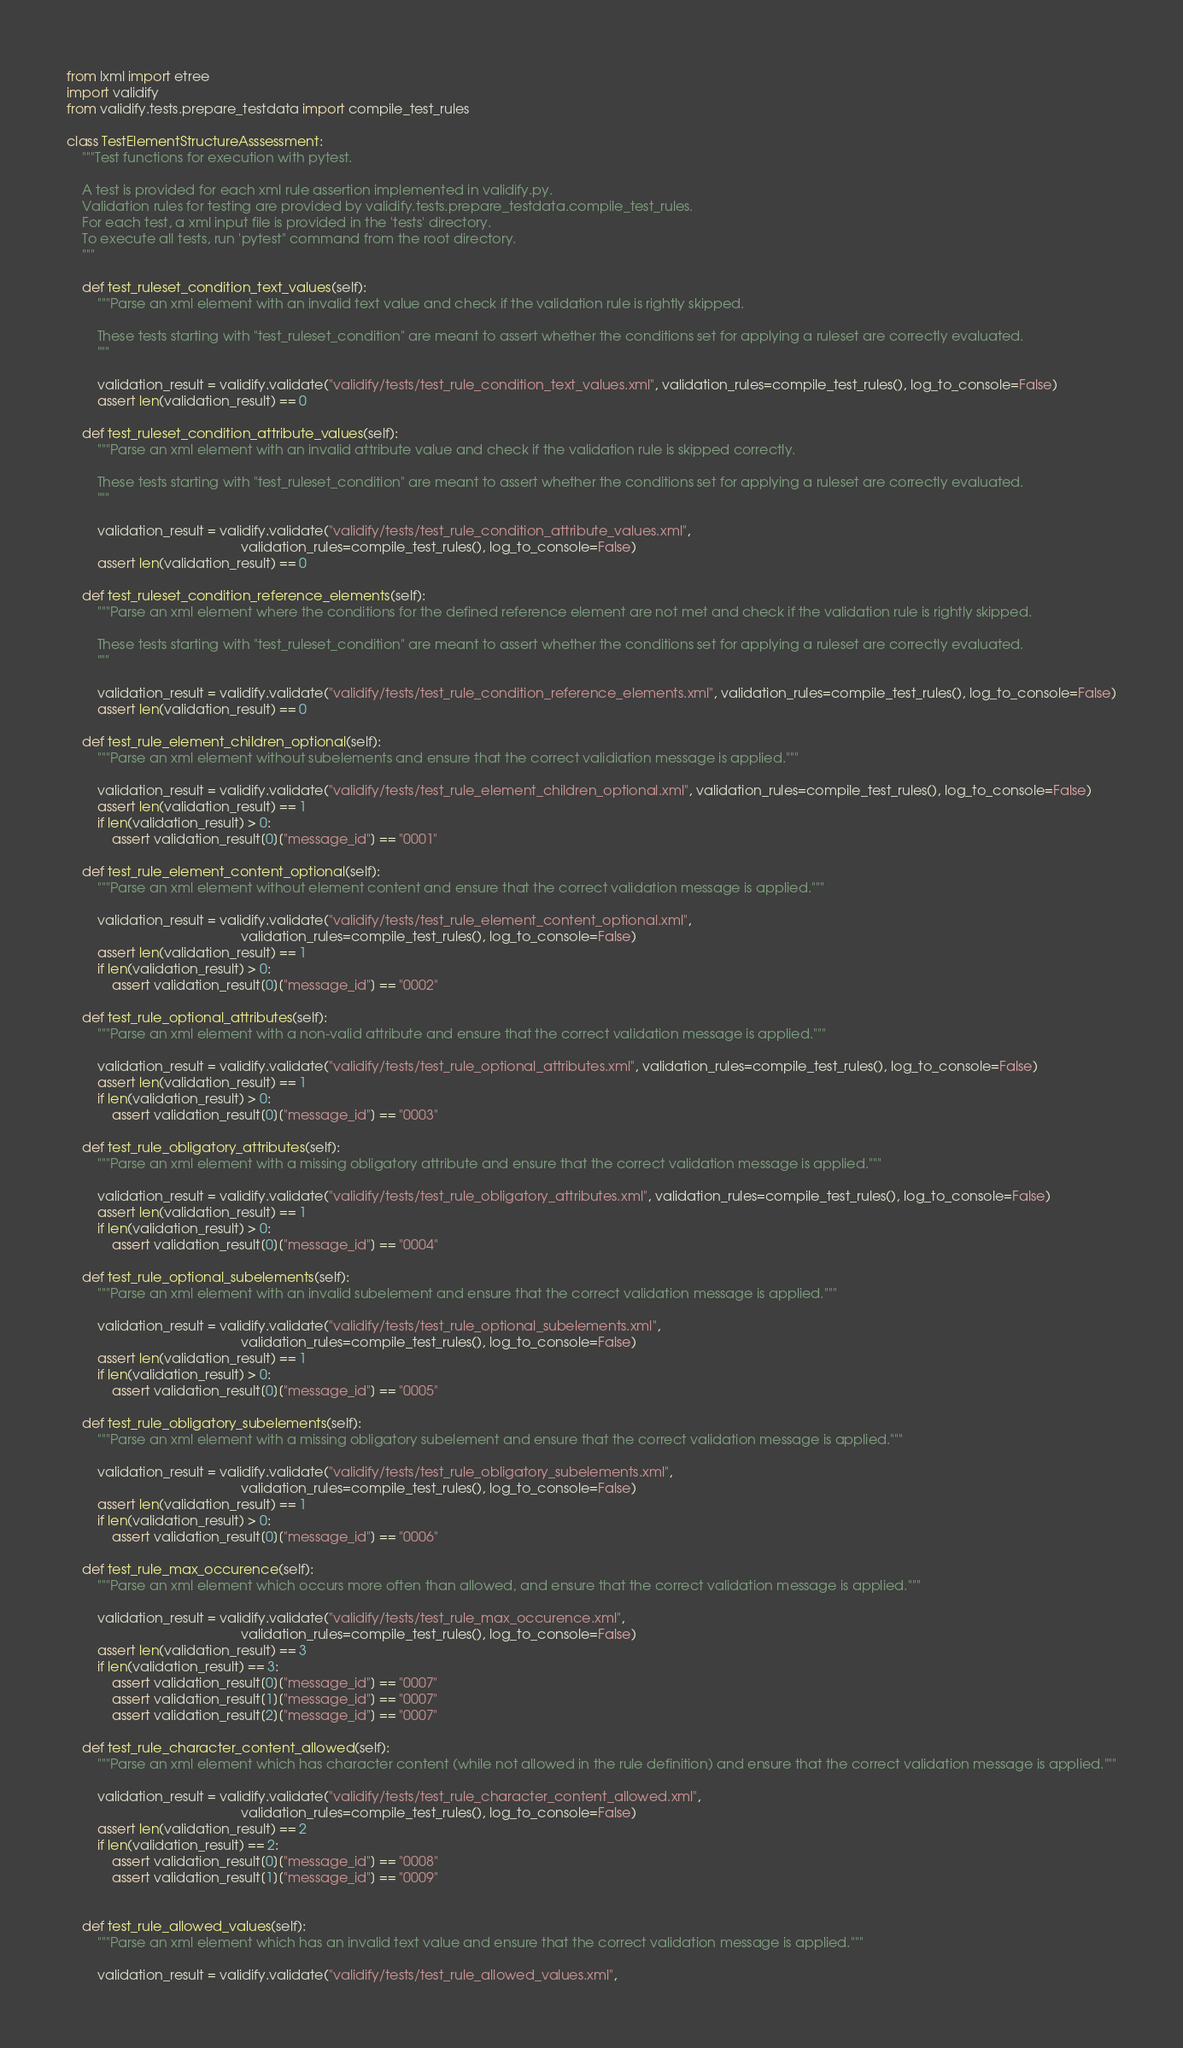<code> <loc_0><loc_0><loc_500><loc_500><_Python_>from lxml import etree
import validify
from validify.tests.prepare_testdata import compile_test_rules

class TestElementStructureAsssessment:
    """Test functions for execution with pytest.

    A test is provided for each xml rule assertion implemented in validify.py.
    Validation rules for testing are provided by validify.tests.prepare_testdata.compile_test_rules.
    For each test, a xml input file is provided in the 'tests' directory.
    To execute all tests, run 'pytest" command from the root directory.
    """

    def test_ruleset_condition_text_values(self):
        """Parse an xml element with an invalid text value and check if the validation rule is rightly skipped.

        These tests starting with "test_ruleset_condition" are meant to assert whether the conditions set for applying a ruleset are correctly evaluated.
        """

        validation_result = validify.validate("validify/tests/test_rule_condition_text_values.xml", validation_rules=compile_test_rules(), log_to_console=False)
        assert len(validation_result) == 0

    def test_ruleset_condition_attribute_values(self):
        """Parse an xml element with an invalid attribute value and check if the validation rule is skipped correctly.

        These tests starting with "test_ruleset_condition" are meant to assert whether the conditions set for applying a ruleset are correctly evaluated.
        """

        validation_result = validify.validate("validify/tests/test_rule_condition_attribute_values.xml",
                                              validation_rules=compile_test_rules(), log_to_console=False)
        assert len(validation_result) == 0

    def test_ruleset_condition_reference_elements(self):
        """Parse an xml element where the conditions for the defined reference element are not met and check if the validation rule is rightly skipped.

        These tests starting with "test_ruleset_condition" are meant to assert whether the conditions set for applying a ruleset are correctly evaluated.
        """

        validation_result = validify.validate("validify/tests/test_rule_condition_reference_elements.xml", validation_rules=compile_test_rules(), log_to_console=False)
        assert len(validation_result) == 0

    def test_rule_element_children_optional(self):
        """Parse an xml element without subelements and ensure that the correct validiation message is applied."""

        validation_result = validify.validate("validify/tests/test_rule_element_children_optional.xml", validation_rules=compile_test_rules(), log_to_console=False)
        assert len(validation_result) == 1
        if len(validation_result) > 0:
            assert validation_result[0]["message_id"] == "0001"

    def test_rule_element_content_optional(self):
        """Parse an xml element without element content and ensure that the correct validation message is applied."""

        validation_result = validify.validate("validify/tests/test_rule_element_content_optional.xml",
                                              validation_rules=compile_test_rules(), log_to_console=False)
        assert len(validation_result) == 1
        if len(validation_result) > 0:
            assert validation_result[0]["message_id"] == "0002"

    def test_rule_optional_attributes(self):
        """Parse an xml element with a non-valid attribute and ensure that the correct validation message is applied."""

        validation_result = validify.validate("validify/tests/test_rule_optional_attributes.xml", validation_rules=compile_test_rules(), log_to_console=False)
        assert len(validation_result) == 1
        if len(validation_result) > 0:
            assert validation_result[0]["message_id"] == "0003"

    def test_rule_obligatory_attributes(self):
        """Parse an xml element with a missing obligatory attribute and ensure that the correct validation message is applied."""

        validation_result = validify.validate("validify/tests/test_rule_obligatory_attributes.xml", validation_rules=compile_test_rules(), log_to_console=False)
        assert len(validation_result) == 1
        if len(validation_result) > 0:
            assert validation_result[0]["message_id"] == "0004"

    def test_rule_optional_subelements(self):
        """Parse an xml element with an invalid subelement and ensure that the correct validation message is applied."""

        validation_result = validify.validate("validify/tests/test_rule_optional_subelements.xml",
                                              validation_rules=compile_test_rules(), log_to_console=False)
        assert len(validation_result) == 1
        if len(validation_result) > 0:
            assert validation_result[0]["message_id"] == "0005"

    def test_rule_obligatory_subelements(self):
        """Parse an xml element with a missing obligatory subelement and ensure that the correct validation message is applied."""

        validation_result = validify.validate("validify/tests/test_rule_obligatory_subelements.xml",
                                              validation_rules=compile_test_rules(), log_to_console=False)
        assert len(validation_result) == 1
        if len(validation_result) > 0:
            assert validation_result[0]["message_id"] == "0006"

    def test_rule_max_occurence(self):
        """Parse an xml element which occurs more often than allowed, and ensure that the correct validation message is applied."""

        validation_result = validify.validate("validify/tests/test_rule_max_occurence.xml",
                                              validation_rules=compile_test_rules(), log_to_console=False)
        assert len(validation_result) == 3
        if len(validation_result) == 3:
            assert validation_result[0]["message_id"] == "0007"
            assert validation_result[1]["message_id"] == "0007"
            assert validation_result[2]["message_id"] == "0007"

    def test_rule_character_content_allowed(self):
        """Parse an xml element which has character content (while not allowed in the rule definition) and ensure that the correct validation message is applied."""

        validation_result = validify.validate("validify/tests/test_rule_character_content_allowed.xml",
                                              validation_rules=compile_test_rules(), log_to_console=False)
        assert len(validation_result) == 2
        if len(validation_result) == 2:
            assert validation_result[0]["message_id"] == "0008"
            assert validation_result[1]["message_id"] == "0009"


    def test_rule_allowed_values(self):
        """Parse an xml element which has an invalid text value and ensure that the correct validation message is applied."""

        validation_result = validify.validate("validify/tests/test_rule_allowed_values.xml",</code> 